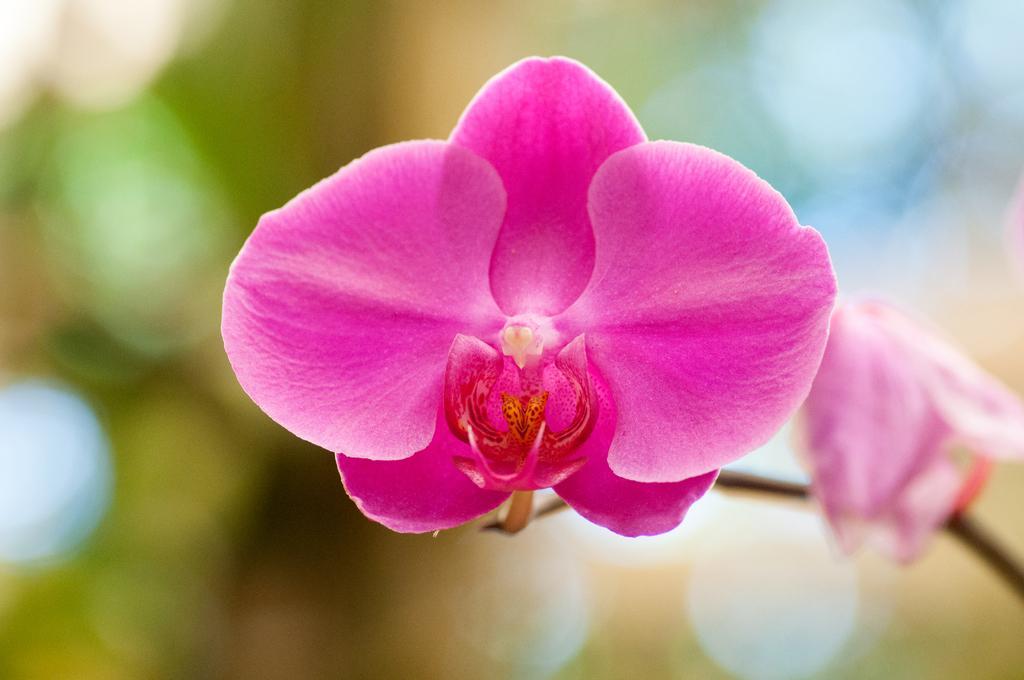How would you summarize this image in a sentence or two? In the image we can see the flower, pink in color and the background is blurred. 